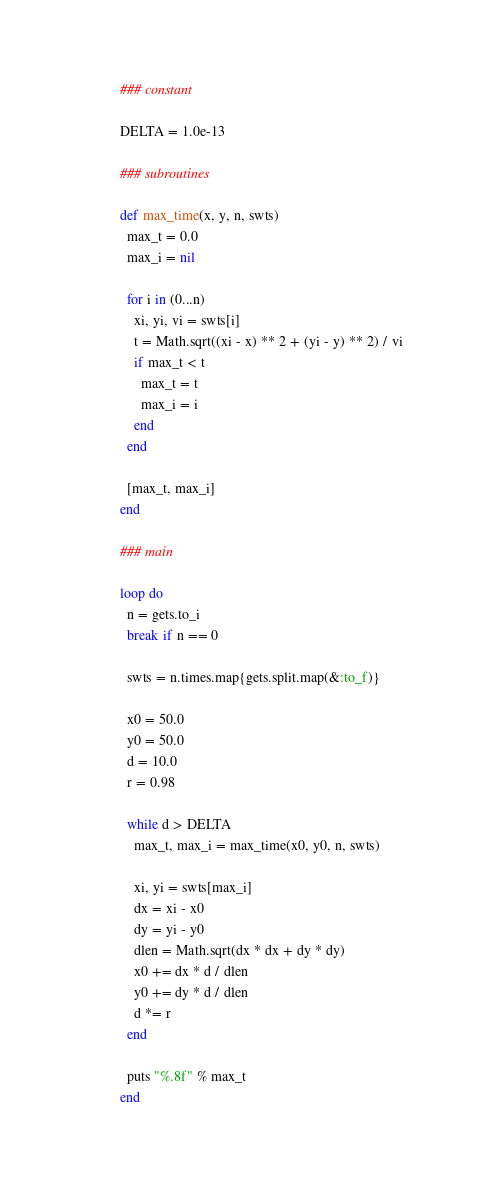<code> <loc_0><loc_0><loc_500><loc_500><_Ruby_>### constant

DELTA = 1.0e-13

### subroutines

def max_time(x, y, n, swts)
  max_t = 0.0
  max_i = nil

  for i in (0...n)
    xi, yi, vi = swts[i]
    t = Math.sqrt((xi - x) ** 2 + (yi - y) ** 2) / vi
    if max_t < t
      max_t = t
      max_i = i
    end
  end

  [max_t, max_i]
end

### main

loop do
  n = gets.to_i
  break if n == 0

  swts = n.times.map{gets.split.map(&:to_f)}

  x0 = 50.0
  y0 = 50.0
  d = 10.0
  r = 0.98

  while d > DELTA
    max_t, max_i = max_time(x0, y0, n, swts)

    xi, yi = swts[max_i]
    dx = xi - x0
    dy = yi - y0
    dlen = Math.sqrt(dx * dx + dy * dy)
    x0 += dx * d / dlen
    y0 += dy * d / dlen
    d *= r
  end

  puts "%.8f" % max_t
end</code> 